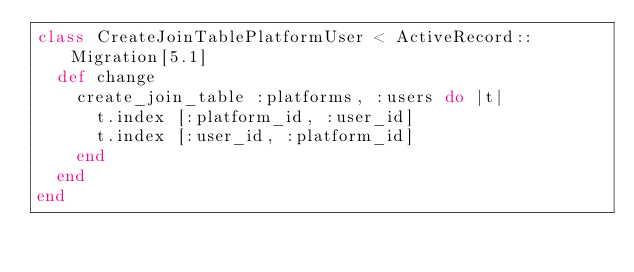Convert code to text. <code><loc_0><loc_0><loc_500><loc_500><_Ruby_>class CreateJoinTablePlatformUser < ActiveRecord::Migration[5.1]
  def change
    create_join_table :platforms, :users do |t|
      t.index [:platform_id, :user_id]
      t.index [:user_id, :platform_id]
    end
  end
end
</code> 